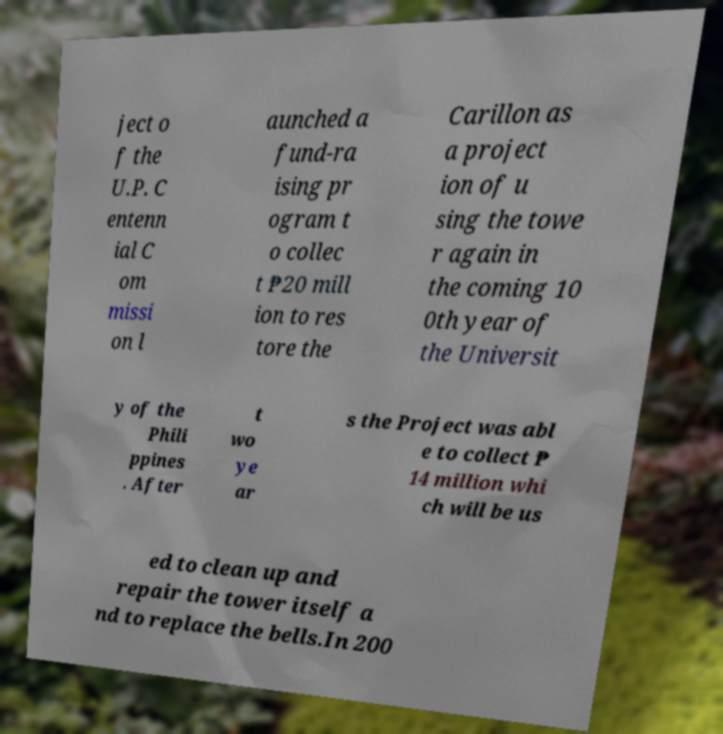Could you assist in decoding the text presented in this image and type it out clearly? ject o f the U.P. C entenn ial C om missi on l aunched a fund-ra ising pr ogram t o collec t ₱20 mill ion to res tore the Carillon as a project ion of u sing the towe r again in the coming 10 0th year of the Universit y of the Phili ppines . After t wo ye ar s the Project was abl e to collect ₱ 14 million whi ch will be us ed to clean up and repair the tower itself a nd to replace the bells.In 200 